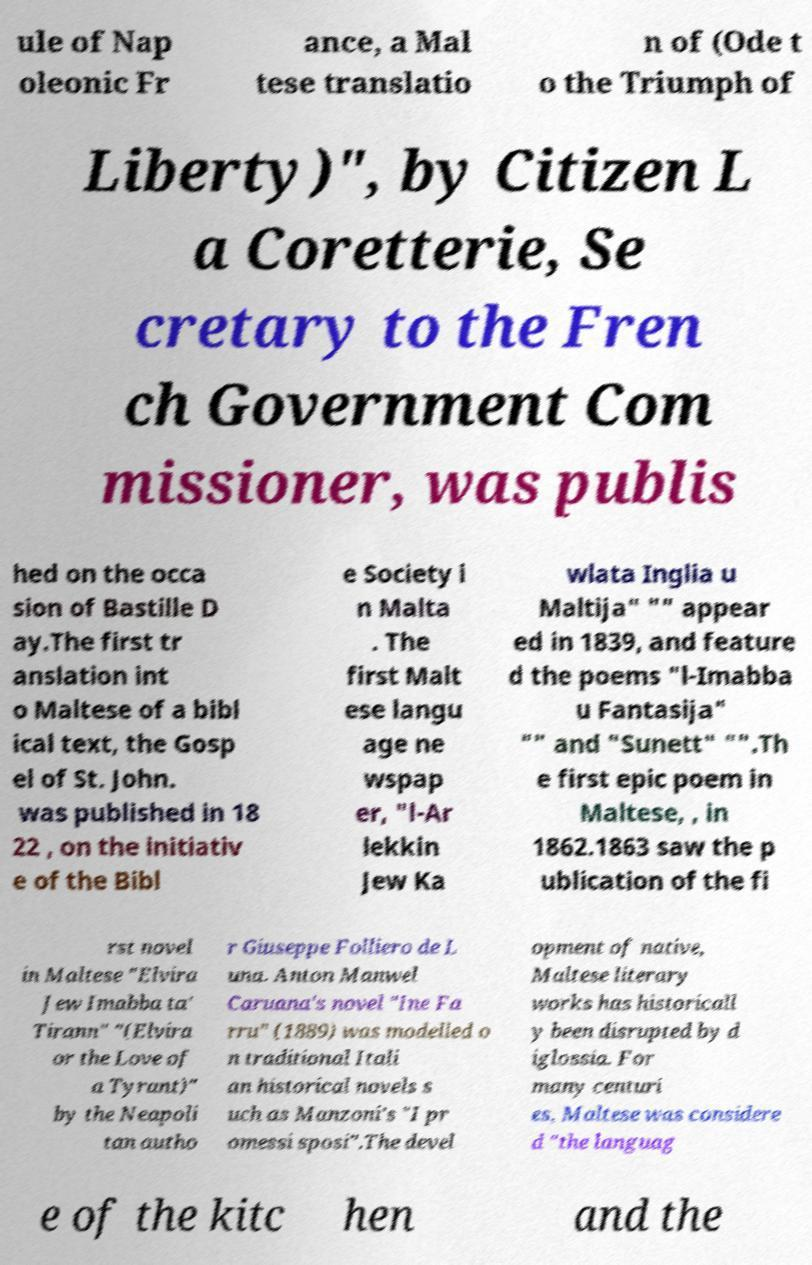Please read and relay the text visible in this image. What does it say? ule of Nap oleonic Fr ance, a Mal tese translatio n of (Ode t o the Triumph of Liberty)", by Citizen L a Coretterie, Se cretary to the Fren ch Government Com missioner, was publis hed on the occa sion of Bastille D ay.The first tr anslation int o Maltese of a bibl ical text, the Gosp el of St. John. was published in 18 22 , on the initiativ e of the Bibl e Society i n Malta . The first Malt ese langu age ne wspap er, "l-Ar lekkin Jew Ka wlata Inglia u Maltija" "" appear ed in 1839, and feature d the poems "l-Imabba u Fantasija" "" and "Sunett" "".Th e first epic poem in Maltese, , in 1862.1863 saw the p ublication of the fi rst novel in Maltese "Elvira Jew Imabba ta' Tirann" "(Elvira or the Love of a Tyrant)" by the Neapoli tan autho r Giuseppe Folliero de L una. Anton Manwel Caruana's novel "Ine Fa rru" (1889) was modelled o n traditional Itali an historical novels s uch as Manzoni's "I pr omessi sposi".The devel opment of native, Maltese literary works has historicall y been disrupted by d iglossia. For many centuri es, Maltese was considere d "the languag e of the kitc hen and the 